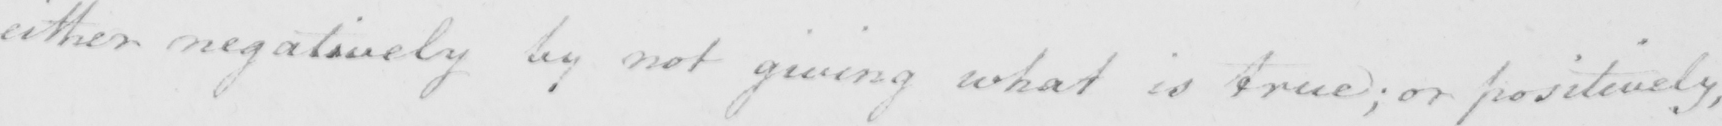Please transcribe the handwritten text in this image. either negatively by not giving what is true ; or positively , 